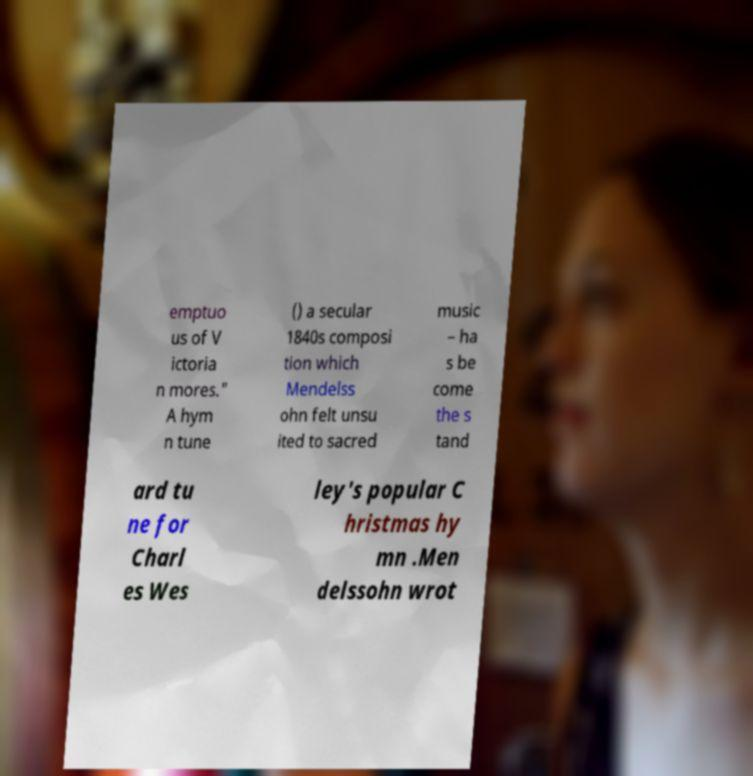What messages or text are displayed in this image? I need them in a readable, typed format. emptuo us of V ictoria n mores." A hym n tune () a secular 1840s composi tion which Mendelss ohn felt unsu ited to sacred music – ha s be come the s tand ard tu ne for Charl es Wes ley's popular C hristmas hy mn .Men delssohn wrot 